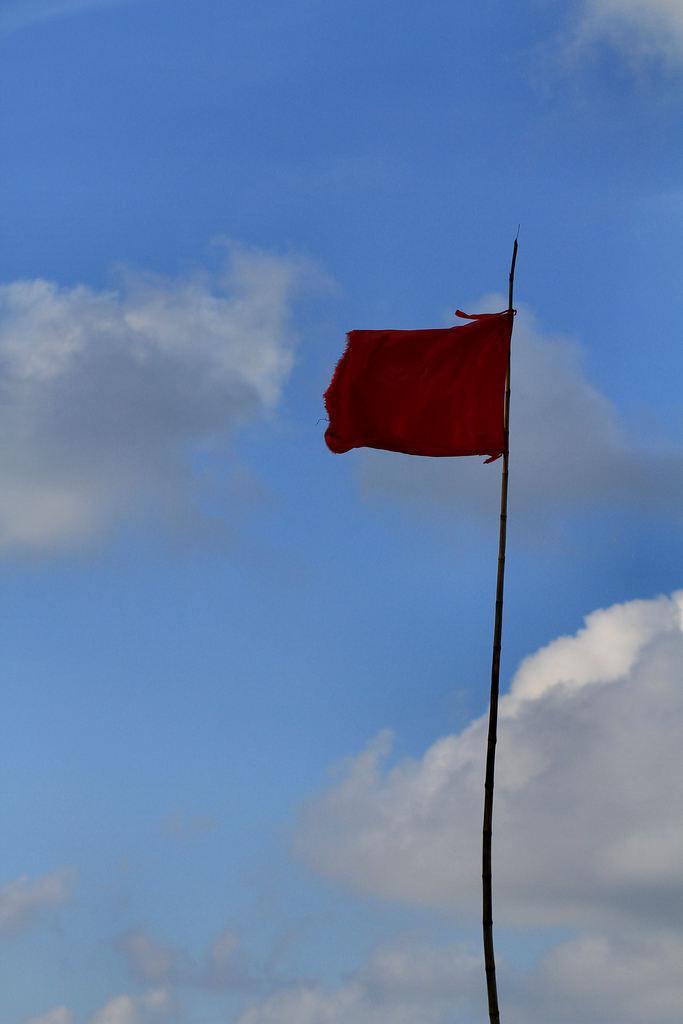In one or two sentences, can you explain what this image depicts? In this picture we can see a flag and in the background we can see sky with clouds. 